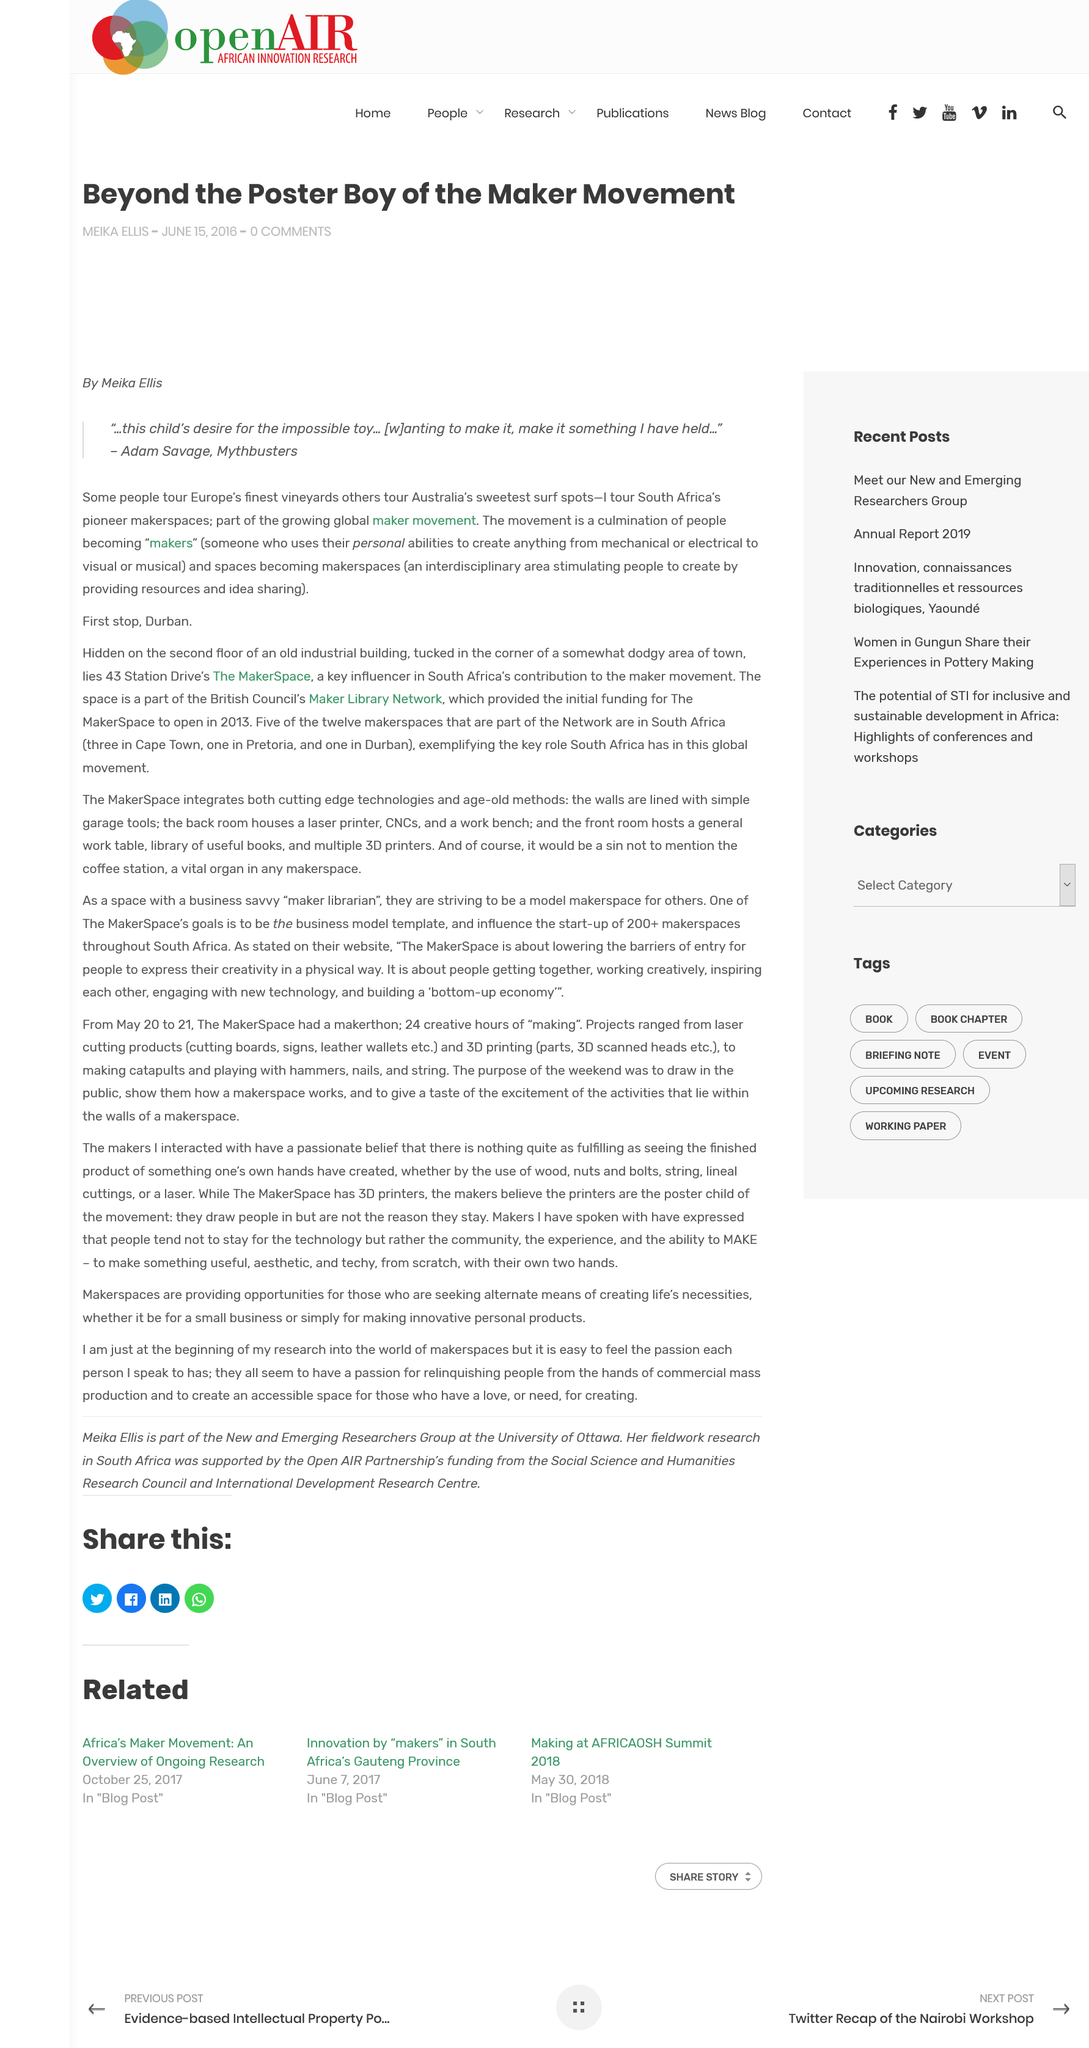List a handful of essential elements in this visual. In June 2016, MIKA ELLIS wrote that the maker movement had a poster boy, but beyond that, there was much more to explore. The Maker movement is a culmination of individuals becoming makers, a movement of people who embrace hands-on creation and innovation. Adam Savage desires to make the impossible toy by creating something he has held in his mind for a long time. 